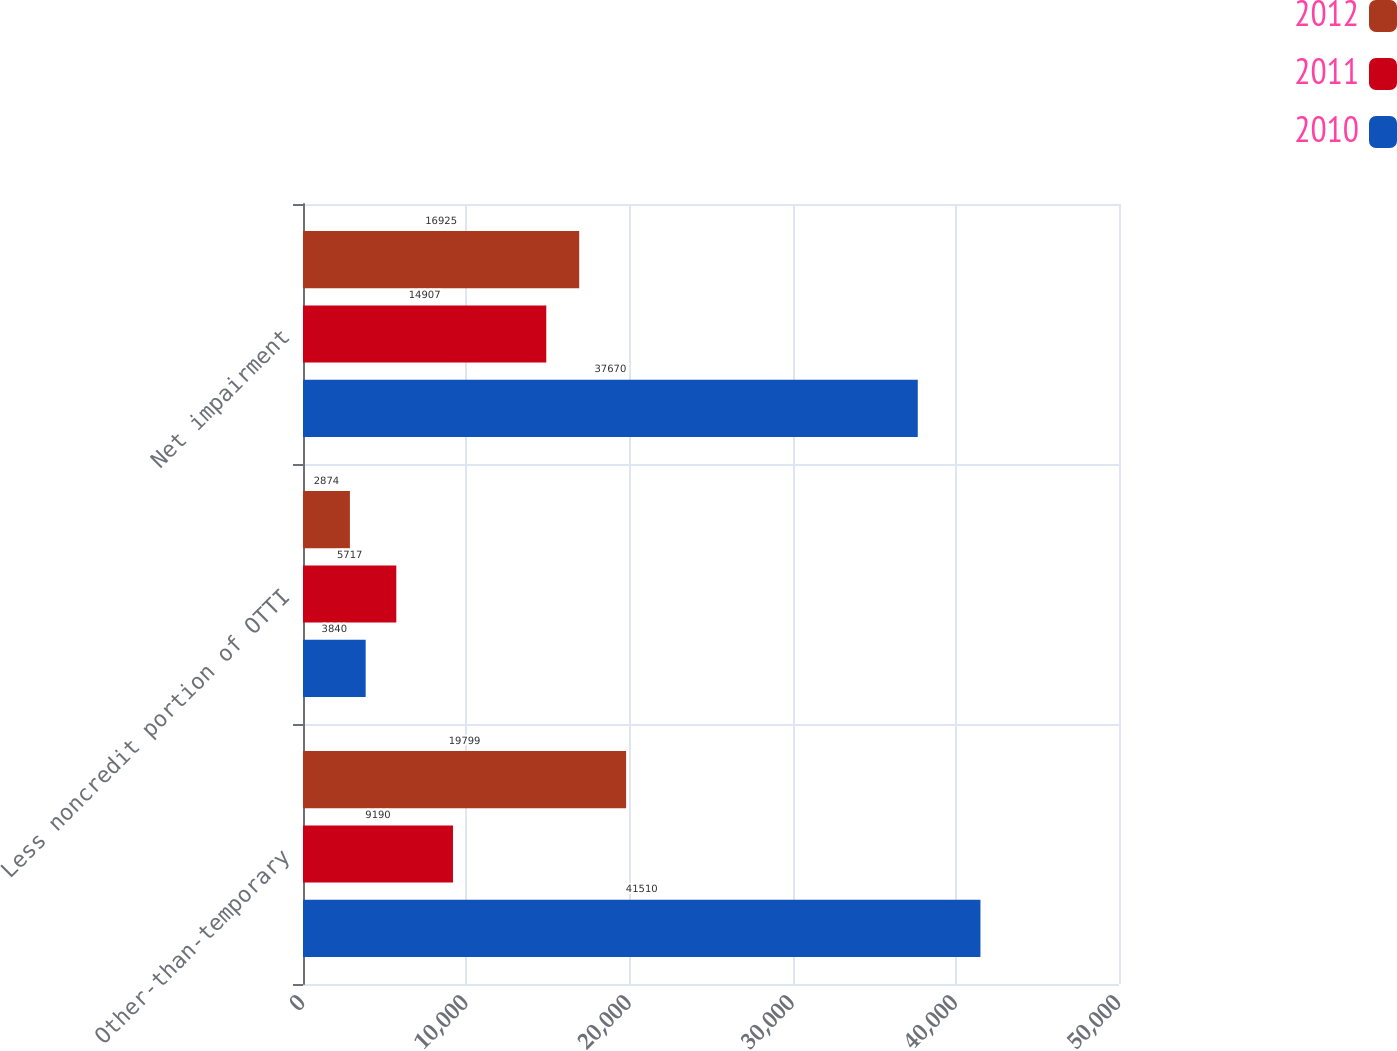Convert chart to OTSL. <chart><loc_0><loc_0><loc_500><loc_500><stacked_bar_chart><ecel><fcel>Other-than-temporary<fcel>Less noncredit portion of OTTI<fcel>Net impairment<nl><fcel>2012<fcel>19799<fcel>2874<fcel>16925<nl><fcel>2011<fcel>9190<fcel>5717<fcel>14907<nl><fcel>2010<fcel>41510<fcel>3840<fcel>37670<nl></chart> 